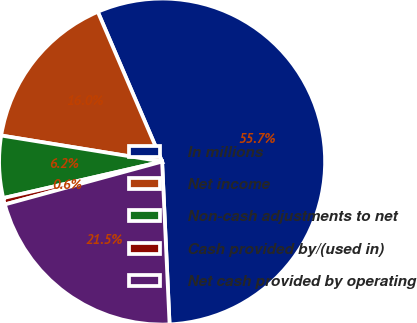Convert chart to OTSL. <chart><loc_0><loc_0><loc_500><loc_500><pie_chart><fcel>In millions<fcel>Net income<fcel>Non-cash adjustments to net<fcel>Cash provided by/(used in)<fcel>Net cash provided by operating<nl><fcel>55.72%<fcel>15.99%<fcel>6.15%<fcel>0.64%<fcel>21.49%<nl></chart> 